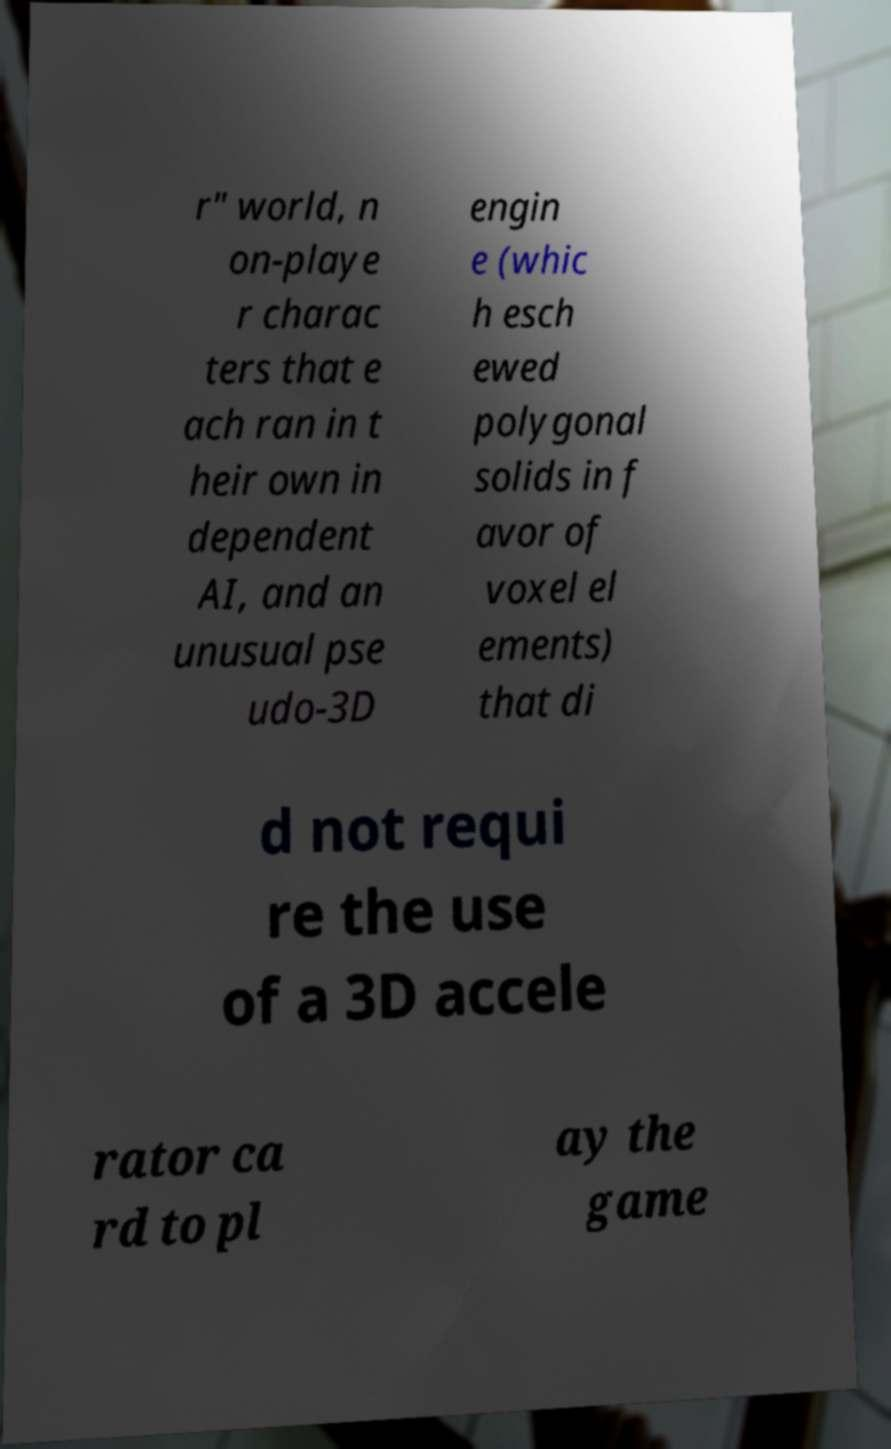Please identify and transcribe the text found in this image. r" world, n on-playe r charac ters that e ach ran in t heir own in dependent AI, and an unusual pse udo-3D engin e (whic h esch ewed polygonal solids in f avor of voxel el ements) that di d not requi re the use of a 3D accele rator ca rd to pl ay the game 